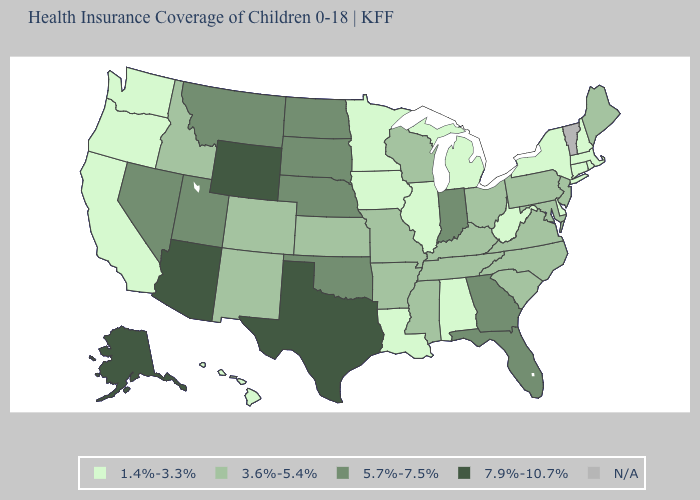Among the states that border Washington , which have the lowest value?
Answer briefly. Oregon. Does North Carolina have the lowest value in the USA?
Concise answer only. No. Which states have the lowest value in the MidWest?
Be succinct. Illinois, Iowa, Michigan, Minnesota. What is the value of Michigan?
Concise answer only. 1.4%-3.3%. Does the map have missing data?
Quick response, please. Yes. What is the value of South Carolina?
Answer briefly. 3.6%-5.4%. Name the states that have a value in the range 3.6%-5.4%?
Concise answer only. Arkansas, Colorado, Idaho, Kansas, Kentucky, Maine, Maryland, Mississippi, Missouri, New Jersey, New Mexico, North Carolina, Ohio, Pennsylvania, South Carolina, Tennessee, Virginia, Wisconsin. Does Georgia have the highest value in the USA?
Keep it brief. No. Among the states that border Vermont , which have the lowest value?
Give a very brief answer. Massachusetts, New Hampshire, New York. Name the states that have a value in the range 3.6%-5.4%?
Be succinct. Arkansas, Colorado, Idaho, Kansas, Kentucky, Maine, Maryland, Mississippi, Missouri, New Jersey, New Mexico, North Carolina, Ohio, Pennsylvania, South Carolina, Tennessee, Virginia, Wisconsin. What is the value of Minnesota?
Short answer required. 1.4%-3.3%. Name the states that have a value in the range 7.9%-10.7%?
Write a very short answer. Alaska, Arizona, Texas, Wyoming. How many symbols are there in the legend?
Short answer required. 5. Does the map have missing data?
Give a very brief answer. Yes. 